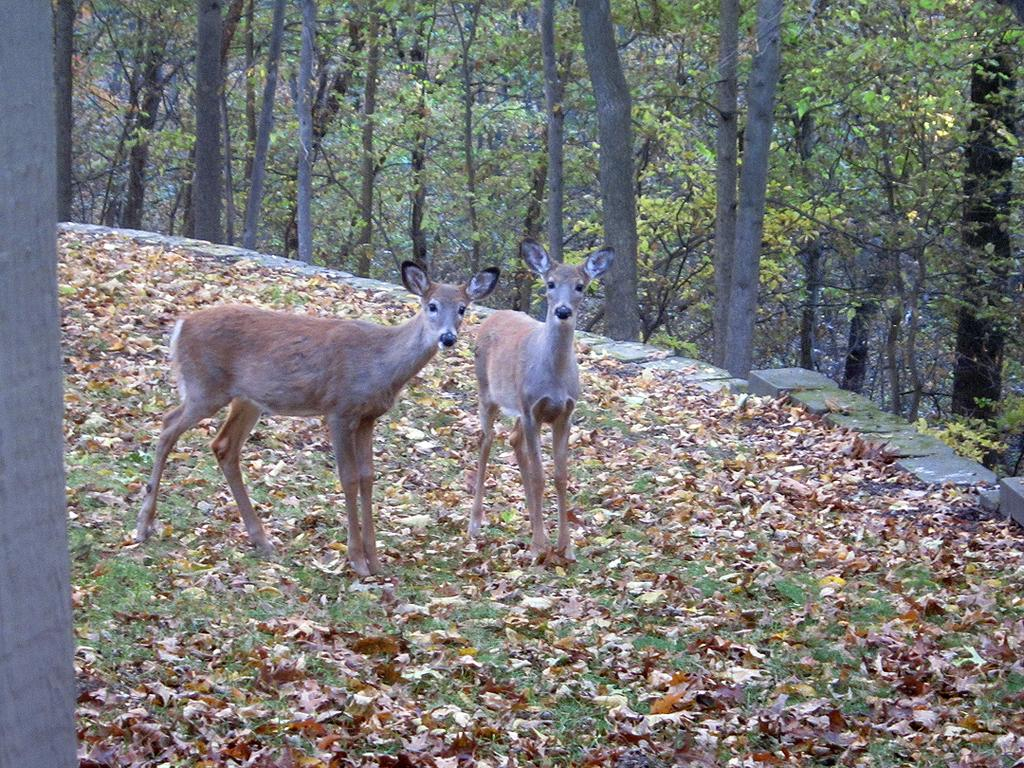What animals are in the center of the image? There are two deers in the center of the image. What can be seen in the background of the image? There are trees in the background of the image. What type of vegetation is present at the bottom of the image? Dried leaves and grass are present at the bottom of the image. What type of wool is being used to make the suit in the image? There is no suit or wool present in the image; it features two deers in a natural setting. How many hens can be seen in the image? There are no hens present in the image; it features two deers and trees in the background. 